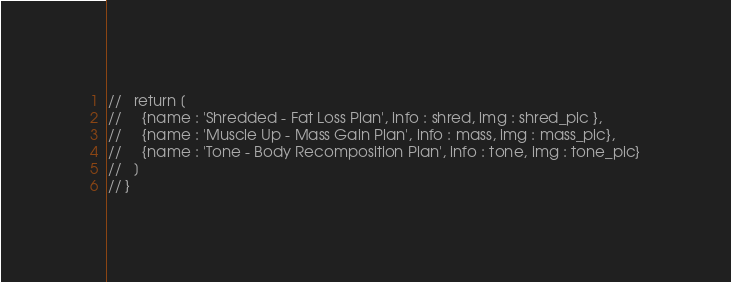Convert code to text. <code><loc_0><loc_0><loc_500><loc_500><_JavaScript_>//   return [
//     {name : 'Shredded - Fat Loss Plan', info : shred, img : shred_pic },
//     {name : 'Muscle Up - Mass Gain Plan', info : mass, img : mass_pic},
//     {name : 'Tone - Body Recomposition Plan', info : tone, img : tone_pic}
//   ]
// }
</code> 